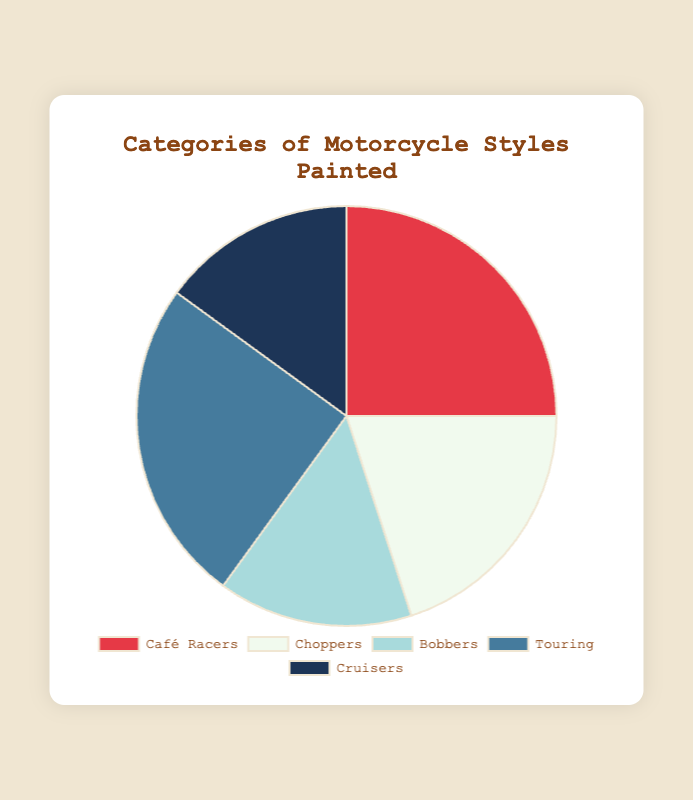What category has the highest percentage? Look at the chart and identify the slice with the largest area. Both "Café Racers" and "Touring" have the largest slices with equal percentages.
Answer: Café Racers and Touring What is the combined percentage of Choppers and Cruisers? Find the slices labeled "Choppers" and "Cruisers" and add their percentages: 20% + 15%.
Answer: 35% Which categories have the same percentage? Compare the sizes of the slices to see which ones are equal. "Café Racers" and "Touring" each have 25%, and "Bobbers" and "Cruisers" each have 15%.
Answer: Café Racers and Touring; Bobbers and Cruisers How much larger is the percentage of Café Racers compared to Bobbers? Subtract the percentage of "Bobbers" from "Café Racers": 25% - 15%.
Answer: 10% Which category is visually represented by a blue color? Identify the blue-colored slice in the chart. "Cruisers" is the category with a blue color.
Answer: Cruisers If you combine the percentages of Café Racers, Choppers, and Bobbers, what total percentage do you get? Add the percentages of the "Café Racers," "Choppers," and "Bobbers": 25% + 20% + 15%.
Answer: 60% Which category has a higher percentage, Choppers or Bobbers? Compare the sizes of the slices for "Choppers" and "Bobbers." Choppers is 20%, and Bobbers is 15%.
Answer: Choppers What is the visual representation of the smallest percentages? The smallest slices represent "Bobbers" and "Cruisers." Both have 15%.
Answer: Bobbers and Cruisers Are the percentages of Touring motorcycles and Cruisers equal? Compare the slices for "Touring" and "Cruisers." "Touring" has 25% while "Cruisers" have 15%.
Answer: No 